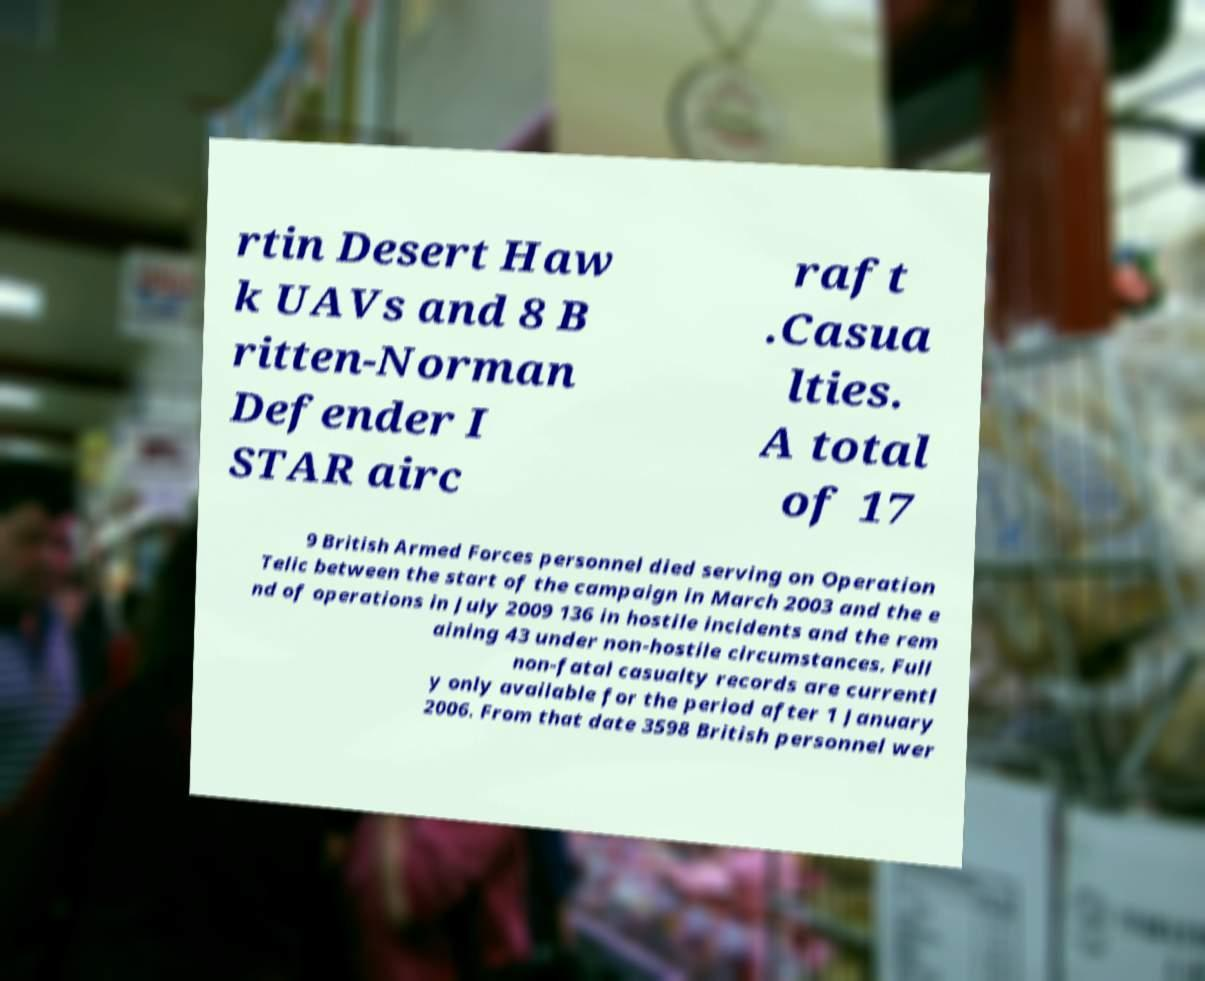I need the written content from this picture converted into text. Can you do that? rtin Desert Haw k UAVs and 8 B ritten-Norman Defender I STAR airc raft .Casua lties. A total of 17 9 British Armed Forces personnel died serving on Operation Telic between the start of the campaign in March 2003 and the e nd of operations in July 2009 136 in hostile incidents and the rem aining 43 under non-hostile circumstances. Full non-fatal casualty records are currentl y only available for the period after 1 January 2006. From that date 3598 British personnel wer 